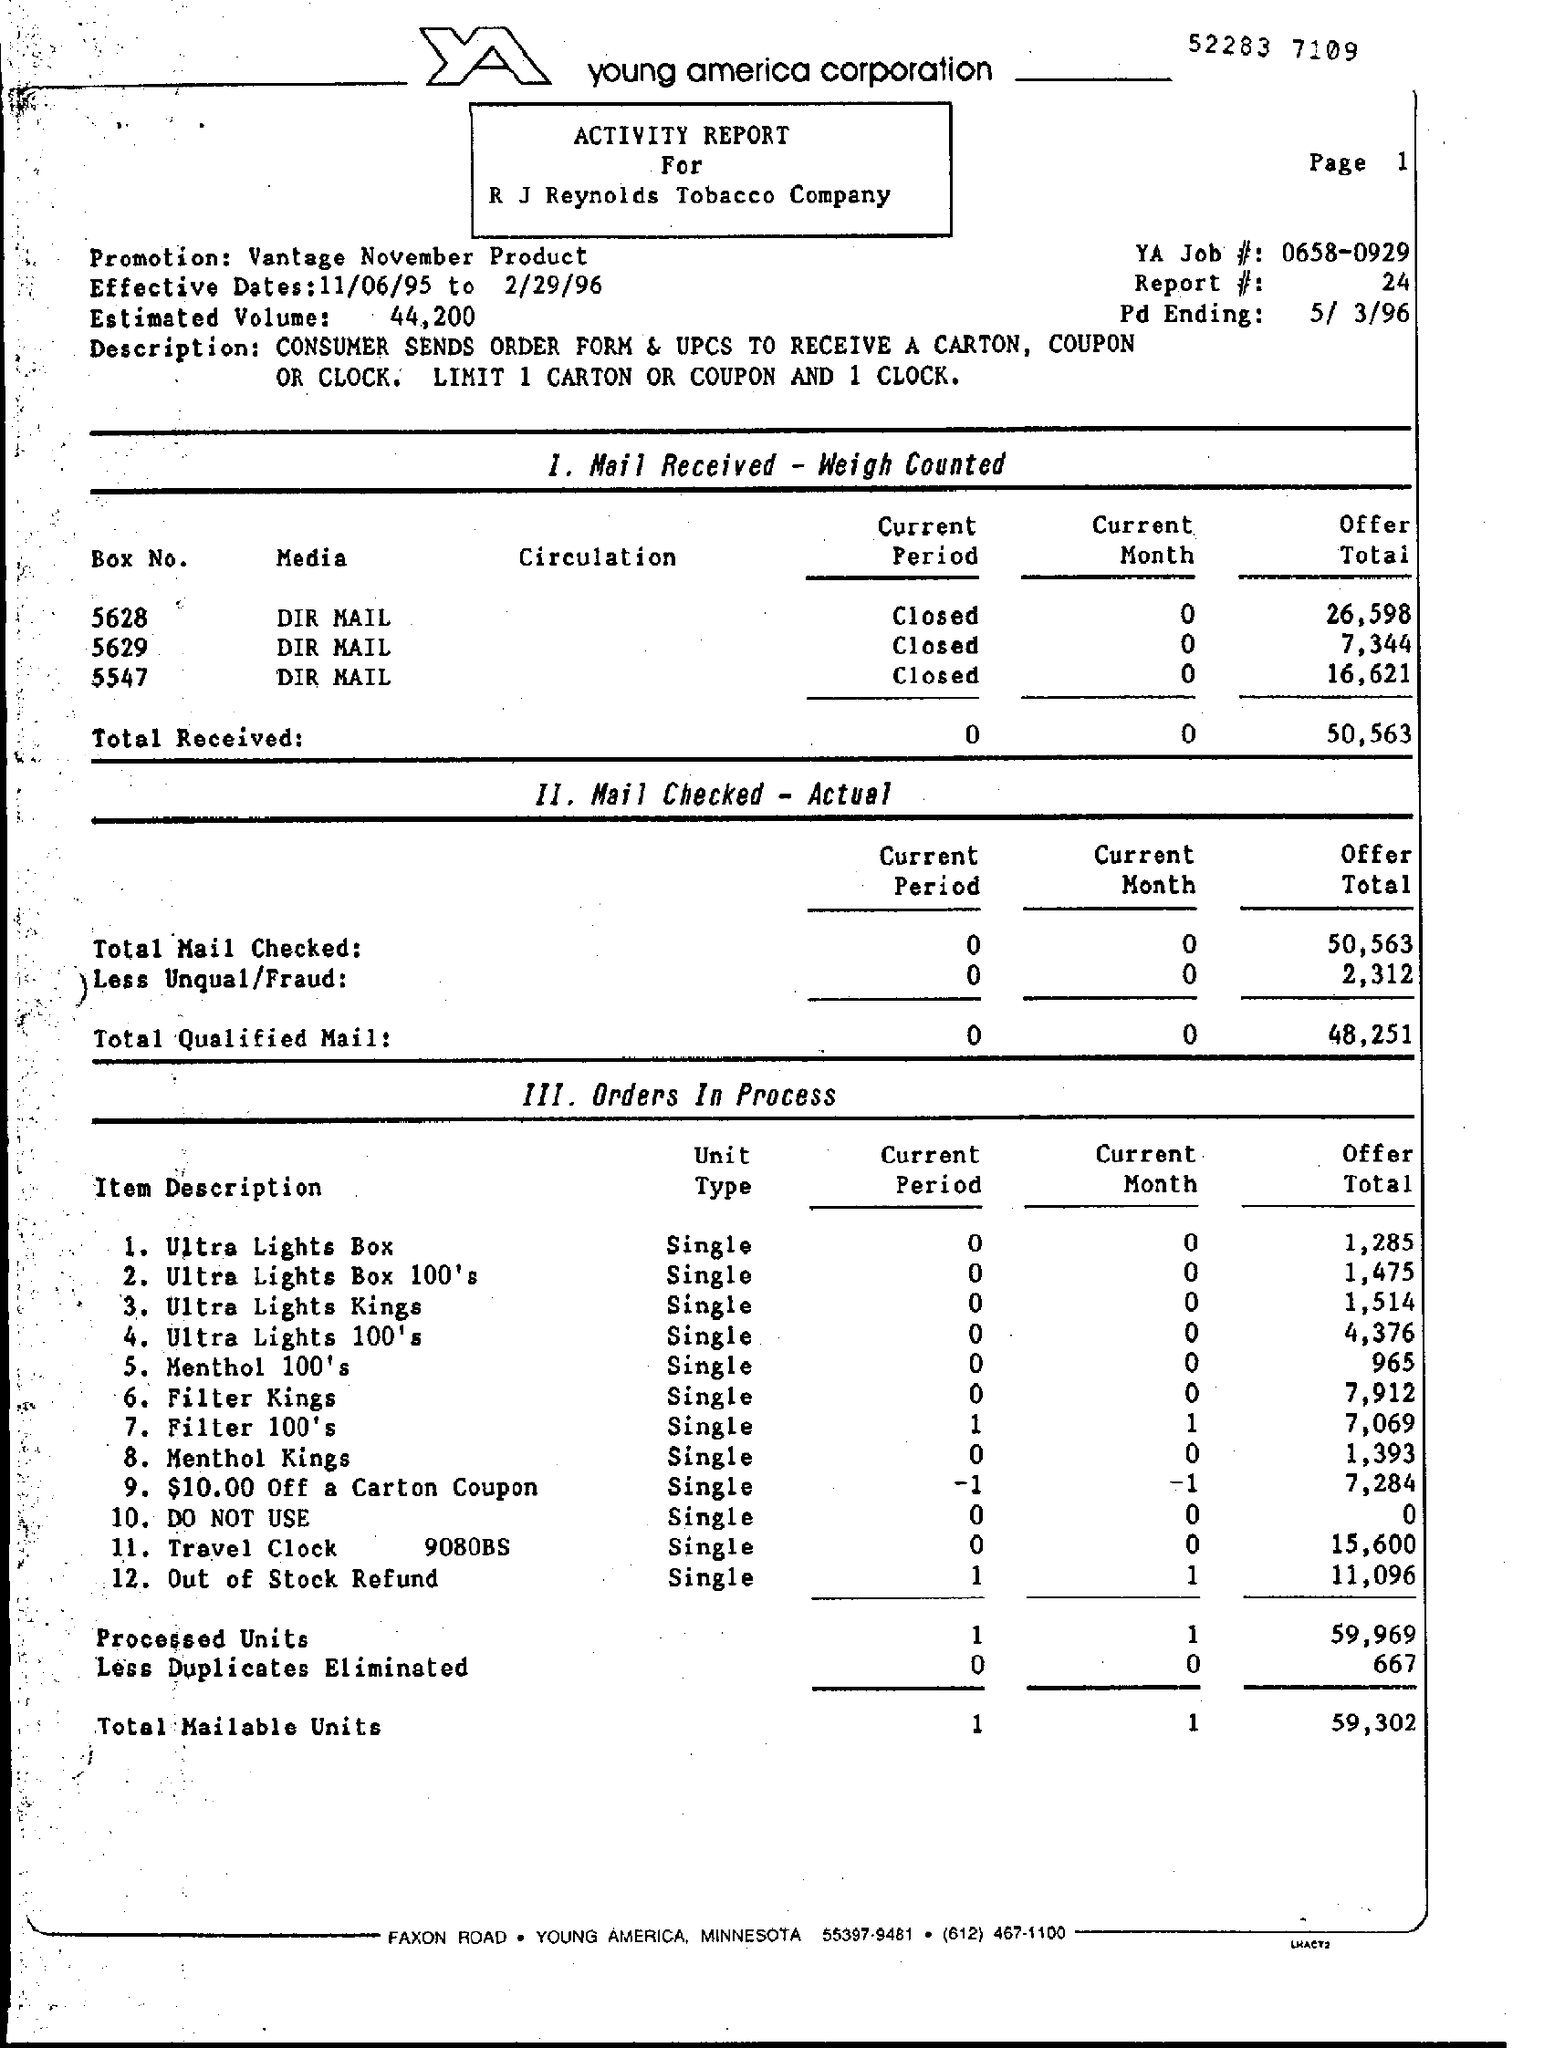Give some essential details in this illustration. The number written at the top of the page is 52,283, and the number written below it is 7,109. The effective dates for a certain period of time are from November 6, 1995 to February 29, 1996. The top of the page mentions Young America Corporation. The YA Job number is 0658-0929. Vantage November Product Promotion: What is it? 